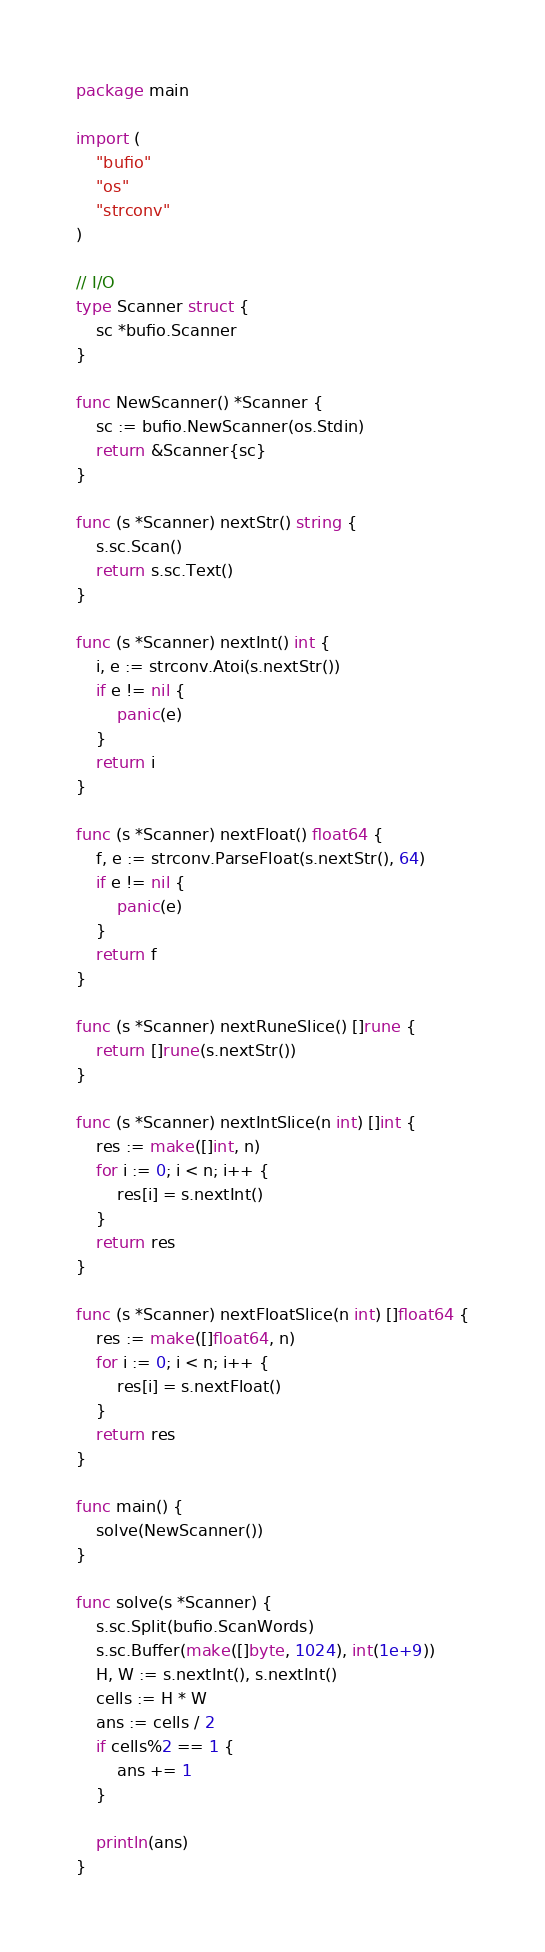<code> <loc_0><loc_0><loc_500><loc_500><_Go_>package main

import (
	"bufio"
	"os"
	"strconv"
)

// I/O
type Scanner struct {
	sc *bufio.Scanner
}

func NewScanner() *Scanner {
	sc := bufio.NewScanner(os.Stdin)
	return &Scanner{sc}
}

func (s *Scanner) nextStr() string {
	s.sc.Scan()
	return s.sc.Text()
}

func (s *Scanner) nextInt() int {
	i, e := strconv.Atoi(s.nextStr())
	if e != nil {
		panic(e)
	}
	return i
}

func (s *Scanner) nextFloat() float64 {
	f, e := strconv.ParseFloat(s.nextStr(), 64)
	if e != nil {
		panic(e)
	}
	return f
}

func (s *Scanner) nextRuneSlice() []rune {
	return []rune(s.nextStr())
}

func (s *Scanner) nextIntSlice(n int) []int {
	res := make([]int, n)
	for i := 0; i < n; i++ {
		res[i] = s.nextInt()
	}
	return res
}

func (s *Scanner) nextFloatSlice(n int) []float64 {
	res := make([]float64, n)
	for i := 0; i < n; i++ {
		res[i] = s.nextFloat()
	}
	return res
}

func main() {
	solve(NewScanner())
}

func solve(s *Scanner) {
	s.sc.Split(bufio.ScanWords)
	s.sc.Buffer(make([]byte, 1024), int(1e+9))
	H, W := s.nextInt(), s.nextInt()
	cells := H * W
	ans := cells / 2
	if cells%2 == 1 {
		ans += 1
	}

	println(ans)
}
</code> 